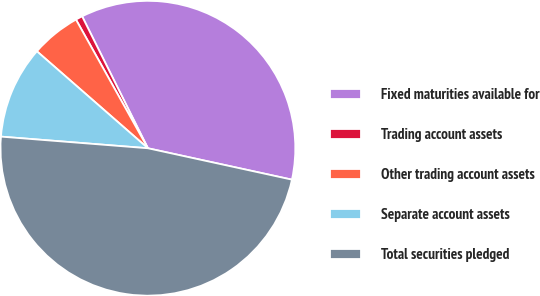<chart> <loc_0><loc_0><loc_500><loc_500><pie_chart><fcel>Fixed maturities available for<fcel>Trading account assets<fcel>Other trading account assets<fcel>Separate account assets<fcel>Total securities pledged<nl><fcel>35.78%<fcel>0.75%<fcel>5.46%<fcel>10.17%<fcel>47.84%<nl></chart> 